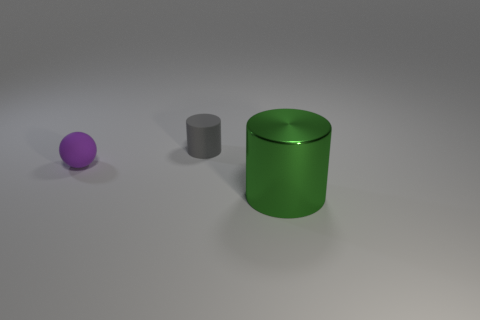Is the number of large metal cylinders that are behind the tiny rubber cylinder the same as the number of gray cylinders in front of the metal cylinder?
Provide a succinct answer. Yes. There is a object that is left of the matte cylinder; is it the same shape as the green object?
Offer a very short reply. No. What number of green objects are spheres or big shiny things?
Offer a very short reply. 1. There is a big thing that is the same shape as the tiny gray rubber thing; what is its material?
Your answer should be very brief. Metal. There is a small thing that is behind the small purple rubber sphere; what shape is it?
Your answer should be compact. Cylinder. Is there a large thing made of the same material as the large cylinder?
Your answer should be very brief. No. Is the purple rubber ball the same size as the green metal thing?
Provide a short and direct response. No. What number of cubes are tiny things or green objects?
Your answer should be very brief. 0. What number of other big metal objects are the same shape as the big metallic object?
Ensure brevity in your answer.  0. Are there more green metal objects on the right side of the green shiny cylinder than tiny gray things to the left of the small gray object?
Your answer should be compact. No. 